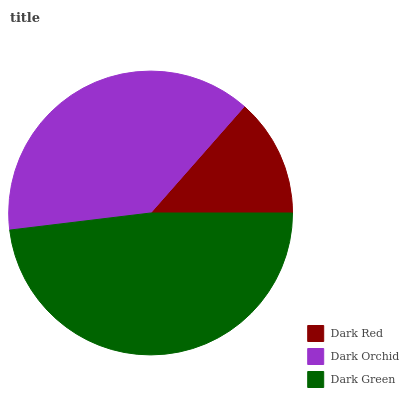Is Dark Red the minimum?
Answer yes or no. Yes. Is Dark Green the maximum?
Answer yes or no. Yes. Is Dark Orchid the minimum?
Answer yes or no. No. Is Dark Orchid the maximum?
Answer yes or no. No. Is Dark Orchid greater than Dark Red?
Answer yes or no. Yes. Is Dark Red less than Dark Orchid?
Answer yes or no. Yes. Is Dark Red greater than Dark Orchid?
Answer yes or no. No. Is Dark Orchid less than Dark Red?
Answer yes or no. No. Is Dark Orchid the high median?
Answer yes or no. Yes. Is Dark Orchid the low median?
Answer yes or no. Yes. Is Dark Green the high median?
Answer yes or no. No. Is Dark Red the low median?
Answer yes or no. No. 